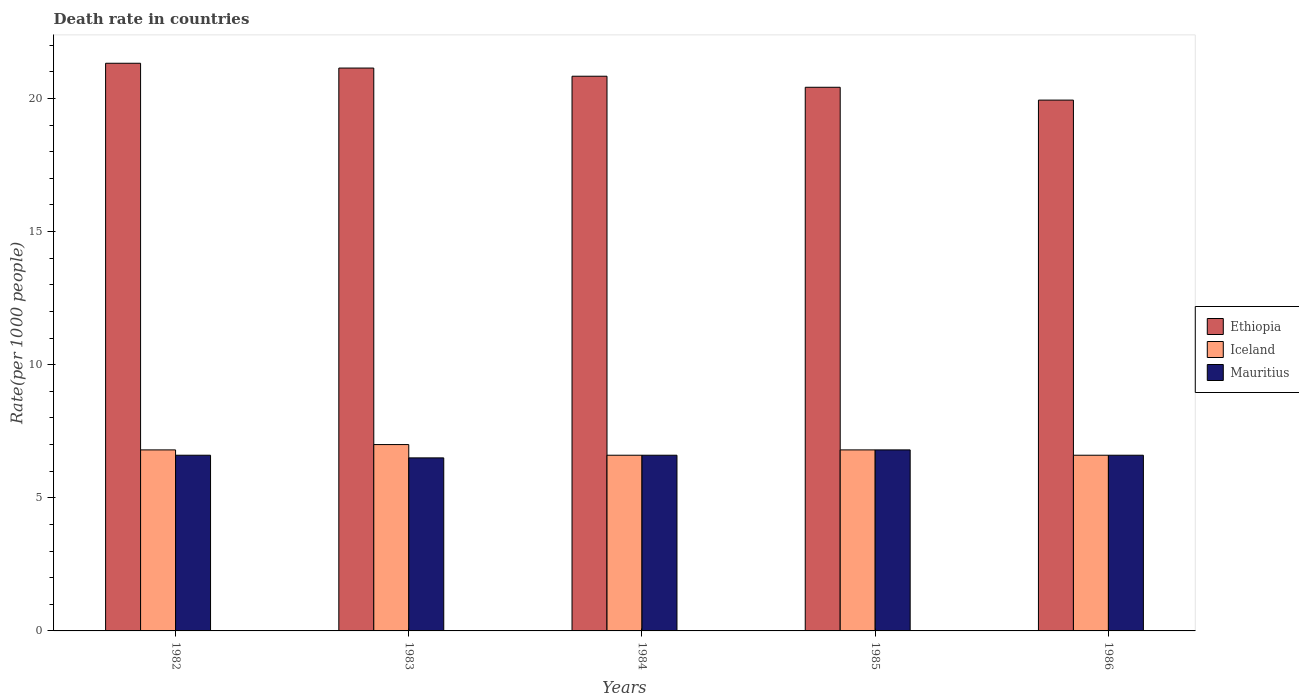How many different coloured bars are there?
Ensure brevity in your answer.  3. How many groups of bars are there?
Keep it short and to the point. 5. Are the number of bars per tick equal to the number of legend labels?
Provide a succinct answer. Yes. How many bars are there on the 5th tick from the left?
Make the answer very short. 3. What is the label of the 2nd group of bars from the left?
Make the answer very short. 1983. In how many cases, is the number of bars for a given year not equal to the number of legend labels?
Provide a succinct answer. 0. What is the death rate in Ethiopia in 1982?
Offer a terse response. 21.32. Across all years, what is the maximum death rate in Mauritius?
Your response must be concise. 6.8. What is the total death rate in Ethiopia in the graph?
Provide a succinct answer. 103.67. What is the difference between the death rate in Mauritius in 1983 and that in 1984?
Your response must be concise. -0.1. What is the difference between the death rate in Iceland in 1985 and the death rate in Mauritius in 1984?
Your response must be concise. 0.2. What is the average death rate in Ethiopia per year?
Your answer should be compact. 20.73. In how many years, is the death rate in Ethiopia greater than 20?
Ensure brevity in your answer.  4. What is the ratio of the death rate in Iceland in 1984 to that in 1985?
Your response must be concise. 0.97. Is the death rate in Ethiopia in 1984 less than that in 1985?
Keep it short and to the point. No. What is the difference between the highest and the second highest death rate in Mauritius?
Your answer should be compact. 0.2. What is the difference between the highest and the lowest death rate in Mauritius?
Offer a very short reply. 0.3. Is the sum of the death rate in Mauritius in 1984 and 1985 greater than the maximum death rate in Iceland across all years?
Keep it short and to the point. Yes. What does the 3rd bar from the left in 1985 represents?
Offer a terse response. Mauritius. What does the 1st bar from the right in 1984 represents?
Ensure brevity in your answer.  Mauritius. Is it the case that in every year, the sum of the death rate in Ethiopia and death rate in Mauritius is greater than the death rate in Iceland?
Provide a short and direct response. Yes. Are all the bars in the graph horizontal?
Make the answer very short. No. How many years are there in the graph?
Keep it short and to the point. 5. Are the values on the major ticks of Y-axis written in scientific E-notation?
Provide a short and direct response. No. Does the graph contain grids?
Offer a terse response. No. Where does the legend appear in the graph?
Keep it short and to the point. Center right. How many legend labels are there?
Provide a succinct answer. 3. What is the title of the graph?
Offer a terse response. Death rate in countries. Does "Ukraine" appear as one of the legend labels in the graph?
Your response must be concise. No. What is the label or title of the Y-axis?
Your answer should be very brief. Rate(per 1000 people). What is the Rate(per 1000 people) of Ethiopia in 1982?
Your answer should be compact. 21.32. What is the Rate(per 1000 people) of Mauritius in 1982?
Your answer should be compact. 6.6. What is the Rate(per 1000 people) of Ethiopia in 1983?
Make the answer very short. 21.14. What is the Rate(per 1000 people) in Iceland in 1983?
Give a very brief answer. 7. What is the Rate(per 1000 people) in Mauritius in 1983?
Your answer should be compact. 6.5. What is the Rate(per 1000 people) in Ethiopia in 1984?
Offer a terse response. 20.84. What is the Rate(per 1000 people) of Iceland in 1984?
Your answer should be compact. 6.6. What is the Rate(per 1000 people) of Mauritius in 1984?
Offer a very short reply. 6.6. What is the Rate(per 1000 people) of Ethiopia in 1985?
Offer a terse response. 20.42. What is the Rate(per 1000 people) in Ethiopia in 1986?
Ensure brevity in your answer.  19.94. What is the Rate(per 1000 people) in Iceland in 1986?
Give a very brief answer. 6.6. What is the Rate(per 1000 people) of Mauritius in 1986?
Make the answer very short. 6.6. Across all years, what is the maximum Rate(per 1000 people) in Ethiopia?
Give a very brief answer. 21.32. Across all years, what is the maximum Rate(per 1000 people) in Iceland?
Keep it short and to the point. 7. Across all years, what is the minimum Rate(per 1000 people) in Ethiopia?
Give a very brief answer. 19.94. What is the total Rate(per 1000 people) in Ethiopia in the graph?
Give a very brief answer. 103.67. What is the total Rate(per 1000 people) of Iceland in the graph?
Your response must be concise. 33.8. What is the total Rate(per 1000 people) of Mauritius in the graph?
Your response must be concise. 33.1. What is the difference between the Rate(per 1000 people) in Ethiopia in 1982 and that in 1983?
Make the answer very short. 0.18. What is the difference between the Rate(per 1000 people) in Ethiopia in 1982 and that in 1984?
Ensure brevity in your answer.  0.49. What is the difference between the Rate(per 1000 people) in Mauritius in 1982 and that in 1984?
Provide a succinct answer. 0. What is the difference between the Rate(per 1000 people) in Ethiopia in 1982 and that in 1985?
Give a very brief answer. 0.9. What is the difference between the Rate(per 1000 people) in Ethiopia in 1982 and that in 1986?
Provide a short and direct response. 1.38. What is the difference between the Rate(per 1000 people) of Iceland in 1982 and that in 1986?
Your answer should be compact. 0.2. What is the difference between the Rate(per 1000 people) of Mauritius in 1982 and that in 1986?
Provide a short and direct response. 0. What is the difference between the Rate(per 1000 people) of Ethiopia in 1983 and that in 1984?
Give a very brief answer. 0.31. What is the difference between the Rate(per 1000 people) of Ethiopia in 1983 and that in 1985?
Keep it short and to the point. 0.72. What is the difference between the Rate(per 1000 people) in Ethiopia in 1983 and that in 1986?
Your answer should be compact. 1.2. What is the difference between the Rate(per 1000 people) of Iceland in 1983 and that in 1986?
Your answer should be compact. 0.4. What is the difference between the Rate(per 1000 people) in Ethiopia in 1984 and that in 1985?
Make the answer very short. 0.41. What is the difference between the Rate(per 1000 people) in Ethiopia in 1984 and that in 1986?
Provide a short and direct response. 0.9. What is the difference between the Rate(per 1000 people) of Mauritius in 1984 and that in 1986?
Offer a very short reply. 0. What is the difference between the Rate(per 1000 people) of Ethiopia in 1985 and that in 1986?
Ensure brevity in your answer.  0.48. What is the difference between the Rate(per 1000 people) of Iceland in 1985 and that in 1986?
Provide a succinct answer. 0.2. What is the difference between the Rate(per 1000 people) in Mauritius in 1985 and that in 1986?
Make the answer very short. 0.2. What is the difference between the Rate(per 1000 people) in Ethiopia in 1982 and the Rate(per 1000 people) in Iceland in 1983?
Offer a terse response. 14.32. What is the difference between the Rate(per 1000 people) of Ethiopia in 1982 and the Rate(per 1000 people) of Mauritius in 1983?
Your answer should be compact. 14.82. What is the difference between the Rate(per 1000 people) in Iceland in 1982 and the Rate(per 1000 people) in Mauritius in 1983?
Provide a succinct answer. 0.3. What is the difference between the Rate(per 1000 people) of Ethiopia in 1982 and the Rate(per 1000 people) of Iceland in 1984?
Give a very brief answer. 14.72. What is the difference between the Rate(per 1000 people) of Ethiopia in 1982 and the Rate(per 1000 people) of Mauritius in 1984?
Your response must be concise. 14.72. What is the difference between the Rate(per 1000 people) of Ethiopia in 1982 and the Rate(per 1000 people) of Iceland in 1985?
Offer a terse response. 14.52. What is the difference between the Rate(per 1000 people) of Ethiopia in 1982 and the Rate(per 1000 people) of Mauritius in 1985?
Give a very brief answer. 14.52. What is the difference between the Rate(per 1000 people) of Iceland in 1982 and the Rate(per 1000 people) of Mauritius in 1985?
Make the answer very short. 0. What is the difference between the Rate(per 1000 people) of Ethiopia in 1982 and the Rate(per 1000 people) of Iceland in 1986?
Your answer should be compact. 14.72. What is the difference between the Rate(per 1000 people) in Ethiopia in 1982 and the Rate(per 1000 people) in Mauritius in 1986?
Provide a succinct answer. 14.72. What is the difference between the Rate(per 1000 people) of Iceland in 1982 and the Rate(per 1000 people) of Mauritius in 1986?
Your response must be concise. 0.2. What is the difference between the Rate(per 1000 people) in Ethiopia in 1983 and the Rate(per 1000 people) in Iceland in 1984?
Ensure brevity in your answer.  14.54. What is the difference between the Rate(per 1000 people) of Ethiopia in 1983 and the Rate(per 1000 people) of Mauritius in 1984?
Offer a terse response. 14.54. What is the difference between the Rate(per 1000 people) in Iceland in 1983 and the Rate(per 1000 people) in Mauritius in 1984?
Your answer should be compact. 0.4. What is the difference between the Rate(per 1000 people) of Ethiopia in 1983 and the Rate(per 1000 people) of Iceland in 1985?
Provide a succinct answer. 14.34. What is the difference between the Rate(per 1000 people) of Ethiopia in 1983 and the Rate(per 1000 people) of Mauritius in 1985?
Make the answer very short. 14.34. What is the difference between the Rate(per 1000 people) in Ethiopia in 1983 and the Rate(per 1000 people) in Iceland in 1986?
Provide a short and direct response. 14.54. What is the difference between the Rate(per 1000 people) in Ethiopia in 1983 and the Rate(per 1000 people) in Mauritius in 1986?
Provide a short and direct response. 14.54. What is the difference between the Rate(per 1000 people) in Ethiopia in 1984 and the Rate(per 1000 people) in Iceland in 1985?
Your answer should be compact. 14.04. What is the difference between the Rate(per 1000 people) of Ethiopia in 1984 and the Rate(per 1000 people) of Mauritius in 1985?
Ensure brevity in your answer.  14.04. What is the difference between the Rate(per 1000 people) in Ethiopia in 1984 and the Rate(per 1000 people) in Iceland in 1986?
Your answer should be very brief. 14.24. What is the difference between the Rate(per 1000 people) in Ethiopia in 1984 and the Rate(per 1000 people) in Mauritius in 1986?
Offer a very short reply. 14.24. What is the difference between the Rate(per 1000 people) in Iceland in 1984 and the Rate(per 1000 people) in Mauritius in 1986?
Your answer should be very brief. 0. What is the difference between the Rate(per 1000 people) in Ethiopia in 1985 and the Rate(per 1000 people) in Iceland in 1986?
Offer a very short reply. 13.82. What is the difference between the Rate(per 1000 people) in Ethiopia in 1985 and the Rate(per 1000 people) in Mauritius in 1986?
Give a very brief answer. 13.82. What is the difference between the Rate(per 1000 people) in Iceland in 1985 and the Rate(per 1000 people) in Mauritius in 1986?
Keep it short and to the point. 0.2. What is the average Rate(per 1000 people) in Ethiopia per year?
Give a very brief answer. 20.73. What is the average Rate(per 1000 people) in Iceland per year?
Provide a short and direct response. 6.76. What is the average Rate(per 1000 people) of Mauritius per year?
Your response must be concise. 6.62. In the year 1982, what is the difference between the Rate(per 1000 people) of Ethiopia and Rate(per 1000 people) of Iceland?
Offer a terse response. 14.52. In the year 1982, what is the difference between the Rate(per 1000 people) in Ethiopia and Rate(per 1000 people) in Mauritius?
Provide a succinct answer. 14.72. In the year 1982, what is the difference between the Rate(per 1000 people) in Iceland and Rate(per 1000 people) in Mauritius?
Give a very brief answer. 0.2. In the year 1983, what is the difference between the Rate(per 1000 people) of Ethiopia and Rate(per 1000 people) of Iceland?
Give a very brief answer. 14.14. In the year 1983, what is the difference between the Rate(per 1000 people) in Ethiopia and Rate(per 1000 people) in Mauritius?
Offer a very short reply. 14.64. In the year 1984, what is the difference between the Rate(per 1000 people) of Ethiopia and Rate(per 1000 people) of Iceland?
Your answer should be compact. 14.24. In the year 1984, what is the difference between the Rate(per 1000 people) in Ethiopia and Rate(per 1000 people) in Mauritius?
Make the answer very short. 14.24. In the year 1985, what is the difference between the Rate(per 1000 people) of Ethiopia and Rate(per 1000 people) of Iceland?
Your response must be concise. 13.62. In the year 1985, what is the difference between the Rate(per 1000 people) in Ethiopia and Rate(per 1000 people) in Mauritius?
Provide a succinct answer. 13.62. In the year 1986, what is the difference between the Rate(per 1000 people) of Ethiopia and Rate(per 1000 people) of Iceland?
Keep it short and to the point. 13.34. In the year 1986, what is the difference between the Rate(per 1000 people) in Ethiopia and Rate(per 1000 people) in Mauritius?
Your answer should be very brief. 13.34. What is the ratio of the Rate(per 1000 people) of Ethiopia in 1982 to that in 1983?
Make the answer very short. 1.01. What is the ratio of the Rate(per 1000 people) of Iceland in 1982 to that in 1983?
Provide a succinct answer. 0.97. What is the ratio of the Rate(per 1000 people) of Mauritius in 1982 to that in 1983?
Provide a succinct answer. 1.02. What is the ratio of the Rate(per 1000 people) of Ethiopia in 1982 to that in 1984?
Keep it short and to the point. 1.02. What is the ratio of the Rate(per 1000 people) in Iceland in 1982 to that in 1984?
Offer a very short reply. 1.03. What is the ratio of the Rate(per 1000 people) of Ethiopia in 1982 to that in 1985?
Your answer should be very brief. 1.04. What is the ratio of the Rate(per 1000 people) in Iceland in 1982 to that in 1985?
Your answer should be very brief. 1. What is the ratio of the Rate(per 1000 people) in Mauritius in 1982 to that in 1985?
Offer a terse response. 0.97. What is the ratio of the Rate(per 1000 people) in Ethiopia in 1982 to that in 1986?
Ensure brevity in your answer.  1.07. What is the ratio of the Rate(per 1000 people) in Iceland in 1982 to that in 1986?
Your answer should be very brief. 1.03. What is the ratio of the Rate(per 1000 people) of Mauritius in 1982 to that in 1986?
Offer a terse response. 1. What is the ratio of the Rate(per 1000 people) of Ethiopia in 1983 to that in 1984?
Offer a terse response. 1.01. What is the ratio of the Rate(per 1000 people) of Iceland in 1983 to that in 1984?
Your answer should be very brief. 1.06. What is the ratio of the Rate(per 1000 people) in Mauritius in 1983 to that in 1984?
Keep it short and to the point. 0.98. What is the ratio of the Rate(per 1000 people) in Ethiopia in 1983 to that in 1985?
Offer a terse response. 1.04. What is the ratio of the Rate(per 1000 people) in Iceland in 1983 to that in 1985?
Your response must be concise. 1.03. What is the ratio of the Rate(per 1000 people) of Mauritius in 1983 to that in 1985?
Make the answer very short. 0.96. What is the ratio of the Rate(per 1000 people) in Ethiopia in 1983 to that in 1986?
Offer a terse response. 1.06. What is the ratio of the Rate(per 1000 people) of Iceland in 1983 to that in 1986?
Make the answer very short. 1.06. What is the ratio of the Rate(per 1000 people) of Ethiopia in 1984 to that in 1985?
Provide a short and direct response. 1.02. What is the ratio of the Rate(per 1000 people) in Iceland in 1984 to that in 1985?
Keep it short and to the point. 0.97. What is the ratio of the Rate(per 1000 people) of Mauritius in 1984 to that in 1985?
Keep it short and to the point. 0.97. What is the ratio of the Rate(per 1000 people) in Ethiopia in 1984 to that in 1986?
Keep it short and to the point. 1.04. What is the ratio of the Rate(per 1000 people) of Ethiopia in 1985 to that in 1986?
Your response must be concise. 1.02. What is the ratio of the Rate(per 1000 people) in Iceland in 1985 to that in 1986?
Your response must be concise. 1.03. What is the ratio of the Rate(per 1000 people) in Mauritius in 1985 to that in 1986?
Ensure brevity in your answer.  1.03. What is the difference between the highest and the second highest Rate(per 1000 people) of Ethiopia?
Keep it short and to the point. 0.18. What is the difference between the highest and the second highest Rate(per 1000 people) in Mauritius?
Ensure brevity in your answer.  0.2. What is the difference between the highest and the lowest Rate(per 1000 people) of Ethiopia?
Provide a succinct answer. 1.38. What is the difference between the highest and the lowest Rate(per 1000 people) in Iceland?
Your answer should be compact. 0.4. What is the difference between the highest and the lowest Rate(per 1000 people) of Mauritius?
Provide a succinct answer. 0.3. 